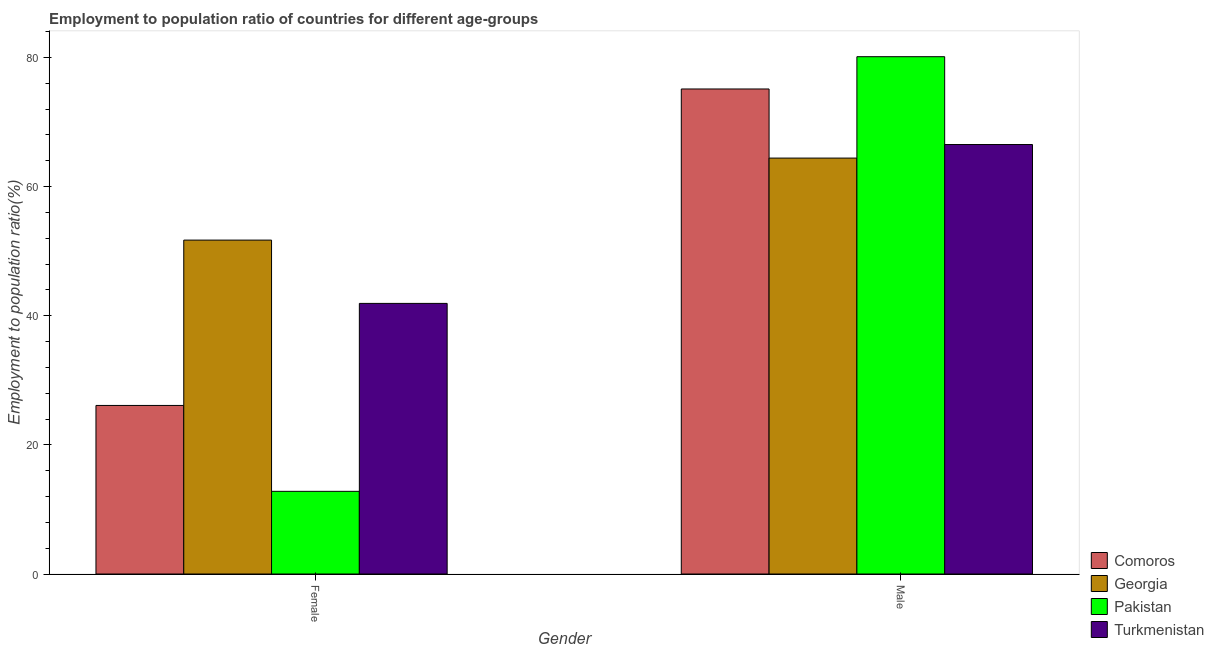How many different coloured bars are there?
Your answer should be compact. 4. How many groups of bars are there?
Keep it short and to the point. 2. Are the number of bars per tick equal to the number of legend labels?
Your answer should be compact. Yes. Are the number of bars on each tick of the X-axis equal?
Offer a terse response. Yes. What is the employment to population ratio(female) in Pakistan?
Provide a short and direct response. 12.8. Across all countries, what is the maximum employment to population ratio(male)?
Your response must be concise. 80.1. Across all countries, what is the minimum employment to population ratio(male)?
Give a very brief answer. 64.4. In which country was the employment to population ratio(female) maximum?
Make the answer very short. Georgia. In which country was the employment to population ratio(male) minimum?
Your response must be concise. Georgia. What is the total employment to population ratio(male) in the graph?
Your answer should be compact. 286.1. What is the difference between the employment to population ratio(female) in Turkmenistan and the employment to population ratio(male) in Georgia?
Your answer should be very brief. -22.5. What is the average employment to population ratio(male) per country?
Your response must be concise. 71.52. What is the difference between the employment to population ratio(male) and employment to population ratio(female) in Comoros?
Your answer should be compact. 49. In how many countries, is the employment to population ratio(female) greater than 76 %?
Provide a short and direct response. 0. What is the ratio of the employment to population ratio(female) in Turkmenistan to that in Comoros?
Offer a terse response. 1.61. Is the employment to population ratio(male) in Georgia less than that in Turkmenistan?
Offer a very short reply. Yes. What does the 2nd bar from the left in Female represents?
Your answer should be very brief. Georgia. Are all the bars in the graph horizontal?
Ensure brevity in your answer.  No. How many countries are there in the graph?
Offer a terse response. 4. What is the difference between two consecutive major ticks on the Y-axis?
Provide a succinct answer. 20. Are the values on the major ticks of Y-axis written in scientific E-notation?
Provide a succinct answer. No. Does the graph contain any zero values?
Offer a terse response. No. Does the graph contain grids?
Provide a short and direct response. No. Where does the legend appear in the graph?
Give a very brief answer. Bottom right. What is the title of the graph?
Your response must be concise. Employment to population ratio of countries for different age-groups. What is the label or title of the Y-axis?
Provide a short and direct response. Employment to population ratio(%). What is the Employment to population ratio(%) in Comoros in Female?
Offer a terse response. 26.1. What is the Employment to population ratio(%) of Georgia in Female?
Give a very brief answer. 51.7. What is the Employment to population ratio(%) in Pakistan in Female?
Provide a short and direct response. 12.8. What is the Employment to population ratio(%) in Turkmenistan in Female?
Provide a succinct answer. 41.9. What is the Employment to population ratio(%) in Comoros in Male?
Offer a terse response. 75.1. What is the Employment to population ratio(%) of Georgia in Male?
Provide a short and direct response. 64.4. What is the Employment to population ratio(%) in Pakistan in Male?
Your answer should be very brief. 80.1. What is the Employment to population ratio(%) in Turkmenistan in Male?
Give a very brief answer. 66.5. Across all Gender, what is the maximum Employment to population ratio(%) in Comoros?
Ensure brevity in your answer.  75.1. Across all Gender, what is the maximum Employment to population ratio(%) in Georgia?
Your response must be concise. 64.4. Across all Gender, what is the maximum Employment to population ratio(%) of Pakistan?
Your answer should be compact. 80.1. Across all Gender, what is the maximum Employment to population ratio(%) in Turkmenistan?
Offer a terse response. 66.5. Across all Gender, what is the minimum Employment to population ratio(%) in Comoros?
Your response must be concise. 26.1. Across all Gender, what is the minimum Employment to population ratio(%) in Georgia?
Offer a very short reply. 51.7. Across all Gender, what is the minimum Employment to population ratio(%) of Pakistan?
Give a very brief answer. 12.8. Across all Gender, what is the minimum Employment to population ratio(%) in Turkmenistan?
Your answer should be very brief. 41.9. What is the total Employment to population ratio(%) in Comoros in the graph?
Give a very brief answer. 101.2. What is the total Employment to population ratio(%) of Georgia in the graph?
Make the answer very short. 116.1. What is the total Employment to population ratio(%) of Pakistan in the graph?
Keep it short and to the point. 92.9. What is the total Employment to population ratio(%) in Turkmenistan in the graph?
Keep it short and to the point. 108.4. What is the difference between the Employment to population ratio(%) in Comoros in Female and that in Male?
Offer a very short reply. -49. What is the difference between the Employment to population ratio(%) of Pakistan in Female and that in Male?
Your response must be concise. -67.3. What is the difference between the Employment to population ratio(%) of Turkmenistan in Female and that in Male?
Offer a very short reply. -24.6. What is the difference between the Employment to population ratio(%) in Comoros in Female and the Employment to population ratio(%) in Georgia in Male?
Ensure brevity in your answer.  -38.3. What is the difference between the Employment to population ratio(%) of Comoros in Female and the Employment to population ratio(%) of Pakistan in Male?
Your response must be concise. -54. What is the difference between the Employment to population ratio(%) of Comoros in Female and the Employment to population ratio(%) of Turkmenistan in Male?
Provide a short and direct response. -40.4. What is the difference between the Employment to population ratio(%) in Georgia in Female and the Employment to population ratio(%) in Pakistan in Male?
Your answer should be compact. -28.4. What is the difference between the Employment to population ratio(%) in Georgia in Female and the Employment to population ratio(%) in Turkmenistan in Male?
Offer a terse response. -14.8. What is the difference between the Employment to population ratio(%) of Pakistan in Female and the Employment to population ratio(%) of Turkmenistan in Male?
Provide a short and direct response. -53.7. What is the average Employment to population ratio(%) in Comoros per Gender?
Your answer should be very brief. 50.6. What is the average Employment to population ratio(%) in Georgia per Gender?
Make the answer very short. 58.05. What is the average Employment to population ratio(%) of Pakistan per Gender?
Keep it short and to the point. 46.45. What is the average Employment to population ratio(%) in Turkmenistan per Gender?
Offer a terse response. 54.2. What is the difference between the Employment to population ratio(%) in Comoros and Employment to population ratio(%) in Georgia in Female?
Give a very brief answer. -25.6. What is the difference between the Employment to population ratio(%) of Comoros and Employment to population ratio(%) of Turkmenistan in Female?
Make the answer very short. -15.8. What is the difference between the Employment to population ratio(%) of Georgia and Employment to population ratio(%) of Pakistan in Female?
Keep it short and to the point. 38.9. What is the difference between the Employment to population ratio(%) in Pakistan and Employment to population ratio(%) in Turkmenistan in Female?
Provide a short and direct response. -29.1. What is the difference between the Employment to population ratio(%) in Comoros and Employment to population ratio(%) in Georgia in Male?
Ensure brevity in your answer.  10.7. What is the difference between the Employment to population ratio(%) in Georgia and Employment to population ratio(%) in Pakistan in Male?
Make the answer very short. -15.7. What is the difference between the Employment to population ratio(%) in Georgia and Employment to population ratio(%) in Turkmenistan in Male?
Offer a terse response. -2.1. What is the ratio of the Employment to population ratio(%) of Comoros in Female to that in Male?
Offer a very short reply. 0.35. What is the ratio of the Employment to population ratio(%) of Georgia in Female to that in Male?
Provide a short and direct response. 0.8. What is the ratio of the Employment to population ratio(%) of Pakistan in Female to that in Male?
Keep it short and to the point. 0.16. What is the ratio of the Employment to population ratio(%) in Turkmenistan in Female to that in Male?
Make the answer very short. 0.63. What is the difference between the highest and the second highest Employment to population ratio(%) in Comoros?
Your response must be concise. 49. What is the difference between the highest and the second highest Employment to population ratio(%) in Pakistan?
Ensure brevity in your answer.  67.3. What is the difference between the highest and the second highest Employment to population ratio(%) in Turkmenistan?
Give a very brief answer. 24.6. What is the difference between the highest and the lowest Employment to population ratio(%) of Comoros?
Make the answer very short. 49. What is the difference between the highest and the lowest Employment to population ratio(%) in Pakistan?
Offer a very short reply. 67.3. What is the difference between the highest and the lowest Employment to population ratio(%) in Turkmenistan?
Offer a terse response. 24.6. 